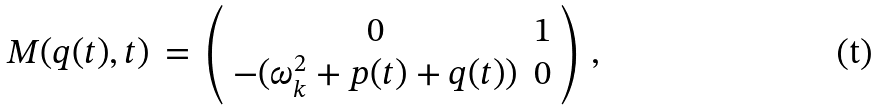Convert formula to latex. <formula><loc_0><loc_0><loc_500><loc_500>M ( q ( t ) , t ) \, = \, \left ( \begin{array} { c c } 0 & 1 \\ - ( \omega _ { k } ^ { 2 } + p ( t ) + q ( t ) ) & 0 \end{array} \right ) \, ,</formula> 